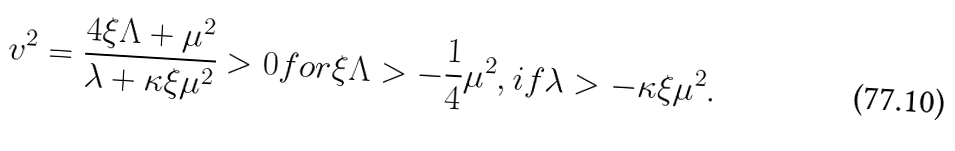<formula> <loc_0><loc_0><loc_500><loc_500>v ^ { 2 } = \frac { 4 \xi \Lambda + \mu ^ { 2 } } { \lambda + \kappa \xi \mu ^ { 2 } } > 0 f o r \xi \Lambda > - \frac { 1 } { 4 } \mu ^ { 2 } , i f \lambda > - \kappa \xi \mu ^ { 2 } .</formula> 